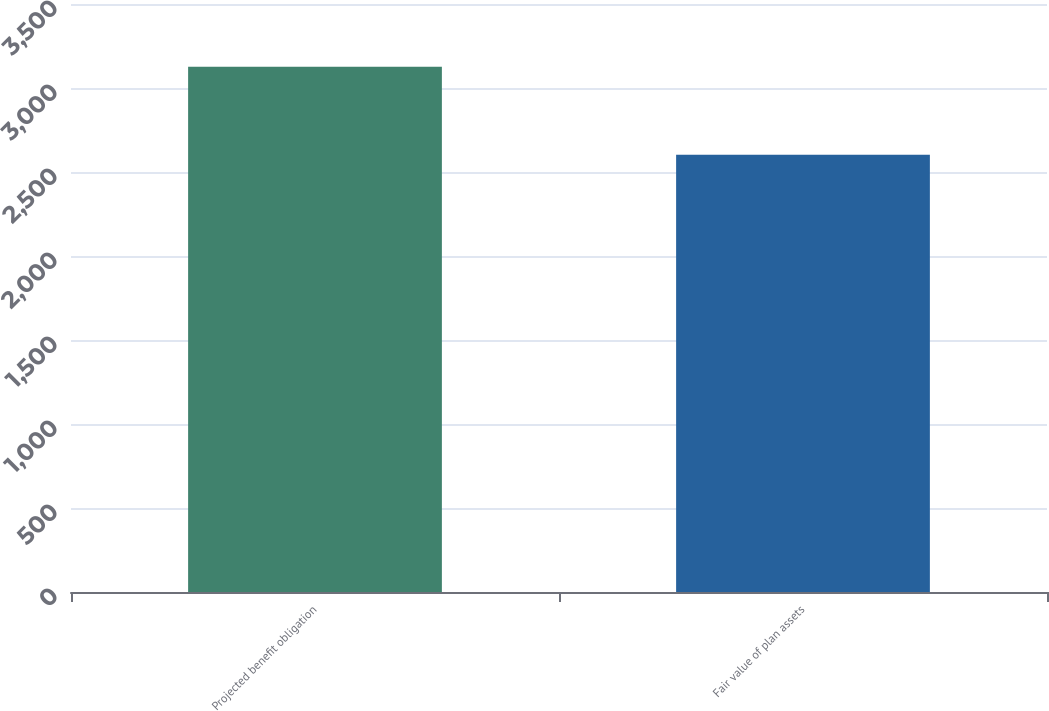Convert chart to OTSL. <chart><loc_0><loc_0><loc_500><loc_500><bar_chart><fcel>Projected benefit obligation<fcel>Fair value of plan assets<nl><fcel>3127<fcel>2603<nl></chart> 